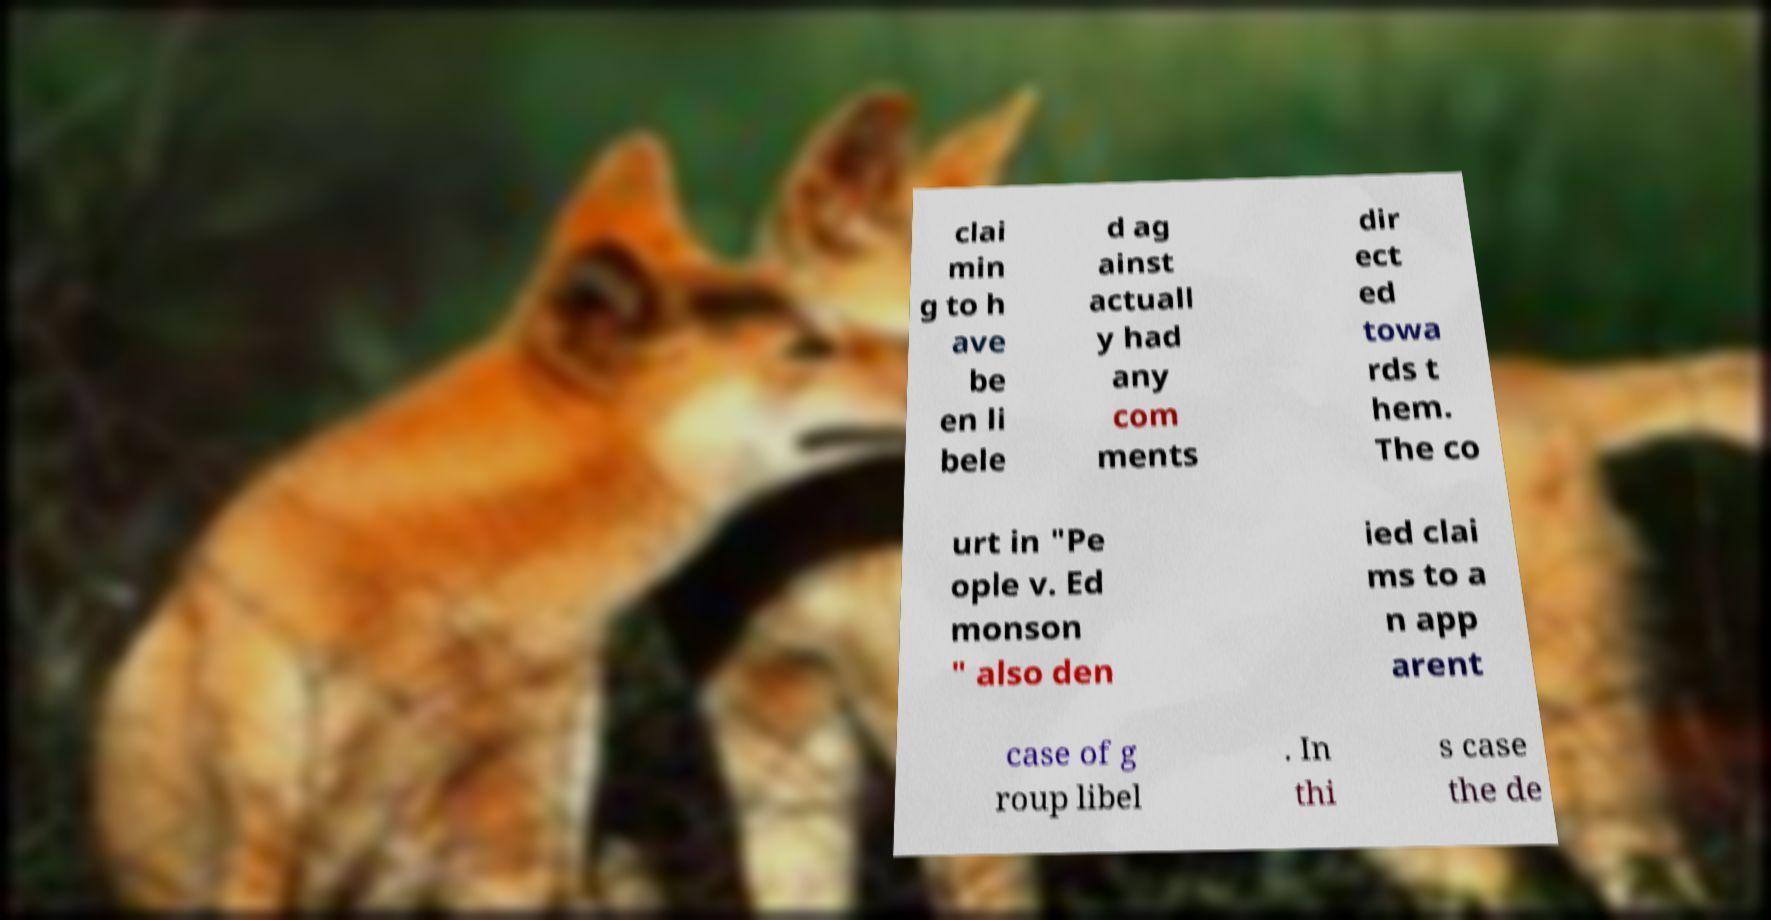Could you extract and type out the text from this image? clai min g to h ave be en li bele d ag ainst actuall y had any com ments dir ect ed towa rds t hem. The co urt in "Pe ople v. Ed monson " also den ied clai ms to a n app arent case of g roup libel . In thi s case the de 